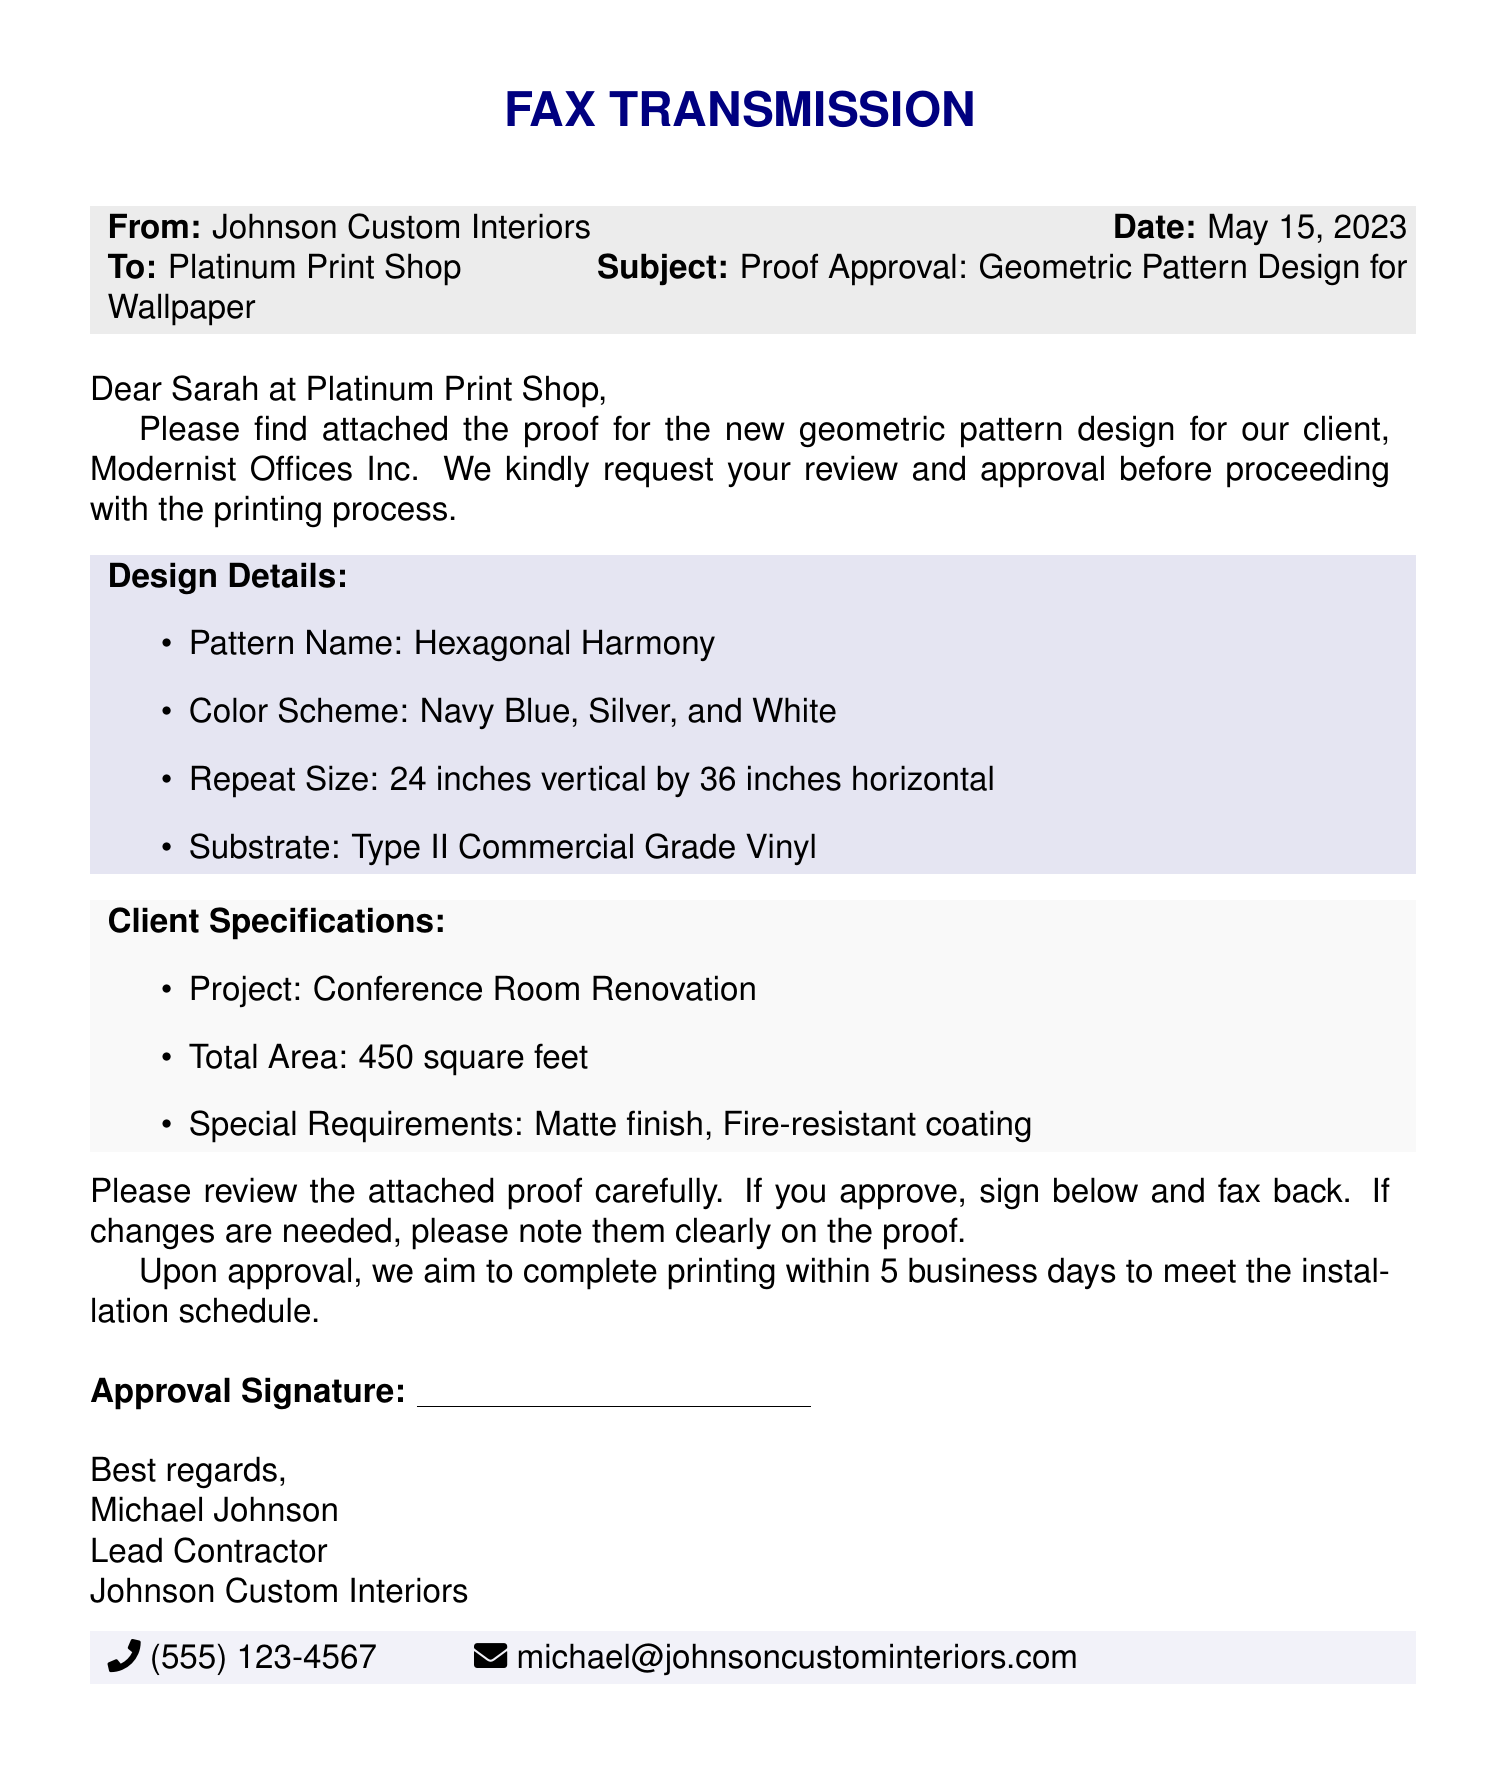What is the pattern name? The pattern name is a specific detail mentioned in the document under Design Details.
Answer: Hexagonal Harmony What are the colors used in the design? The color scheme is explicitly listed in the Design Details section of the document.
Answer: Navy Blue, Silver, and White What is the total area of the project? The total area is clearly stated in the Client Specifications section.
Answer: 450 square feet What is the substrate type? The substrate type is provided in the Design Details section of the fax.
Answer: Type II Commercial Grade Vinyl What is the date of the fax transmission? The date of the fax is included in the header of the document.
Answer: May 15, 2023 What type of finish is specified by the client? The special requirements concerning the finish can be found under Client Specifications.
Answer: Matte finish What is needed from the print shop for approval? The section detailing the required response from the print shop mentions specific requirements for the approval process.
Answer: Signature How long after approval will printing be completed? The timeline for printing is mentioned towards the end of the document, providing a clear timeframe.
Answer: 5 business days What is the project for which the wallpaper is being designed? The project specification is outlined under the Client Specifications section.
Answer: Conference Room Renovation 